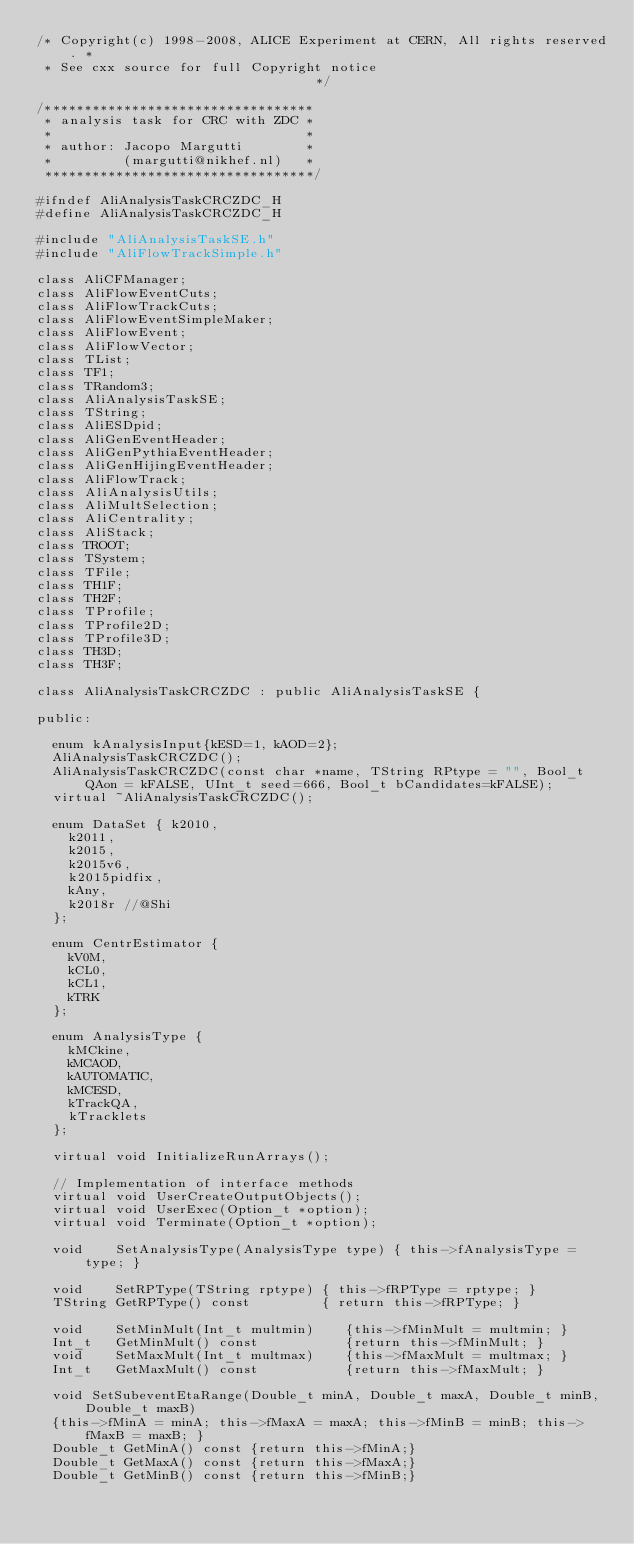<code> <loc_0><loc_0><loc_500><loc_500><_C_>/* Copyright(c) 1998-2008, ALICE Experiment at CERN, All rights reserved. *
 * See cxx source for full Copyright notice                               */

/**********************************
 * analysis task for CRC with ZDC *
 *                                *
 * author: Jacopo Margutti        *
 *         (margutti@nikhef.nl)   *
 **********************************/

#ifndef AliAnalysisTaskCRCZDC_H
#define AliAnalysisTaskCRCZDC_H

#include "AliAnalysisTaskSE.h"
#include "AliFlowTrackSimple.h"

class AliCFManager;
class AliFlowEventCuts;
class AliFlowTrackCuts;
class AliFlowEventSimpleMaker;
class AliFlowEvent;
class AliFlowVector;
class TList;
class TF1;
class TRandom3;
class AliAnalysisTaskSE;
class TString;
class AliESDpid;
class AliGenEventHeader;
class AliGenPythiaEventHeader;
class AliGenHijingEventHeader;
class AliFlowTrack;
class AliAnalysisUtils;
class AliMultSelection;
class AliCentrality;
class AliStack;
class TROOT;
class TSystem;
class TFile;
class TH1F;
class TH2F;
class TProfile;
class TProfile2D;
class TProfile3D;
class TH3D;
class TH3F;

class AliAnalysisTaskCRCZDC : public AliAnalysisTaskSE {

public:

  enum kAnalysisInput{kESD=1, kAOD=2};
  AliAnalysisTaskCRCZDC();
  AliAnalysisTaskCRCZDC(const char *name, TString RPtype = "", Bool_t QAon = kFALSE, UInt_t seed=666, Bool_t bCandidates=kFALSE);
  virtual ~AliAnalysisTaskCRCZDC();

  enum DataSet { k2010,
    k2011,
    k2015,
    k2015v6,
    k2015pidfix,
    kAny,
    k2018r //@Shi
  };

  enum CentrEstimator {
    kV0M,
    kCL0,
    kCL1,
    kTRK
  };

  enum AnalysisType {
    kMCkine,
    kMCAOD,
    kAUTOMATIC,
    kMCESD,
    kTrackQA,
    kTracklets
  };

  virtual void InitializeRunArrays();

  // Implementation of interface methods
  virtual void UserCreateOutputObjects();
  virtual void UserExec(Option_t *option);
  virtual void Terminate(Option_t *option);

  void    SetAnalysisType(AnalysisType type) { this->fAnalysisType = type; }

  void    SetRPType(TString rptype) { this->fRPType = rptype; }
  TString GetRPType() const         { return this->fRPType; }

  void    SetMinMult(Int_t multmin)    {this->fMinMult = multmin; }
  Int_t   GetMinMult() const           {return this->fMinMult; }
  void    SetMaxMult(Int_t multmax)    {this->fMaxMult = multmax; }
  Int_t   GetMaxMult() const           {return this->fMaxMult; }

  void SetSubeventEtaRange(Double_t minA, Double_t maxA, Double_t minB, Double_t maxB)
  {this->fMinA = minA; this->fMaxA = maxA; this->fMinB = minB; this->fMaxB = maxB; }
  Double_t GetMinA() const {return this->fMinA;}
  Double_t GetMaxA() const {return this->fMaxA;}
  Double_t GetMinB() const {return this->fMinB;}</code> 